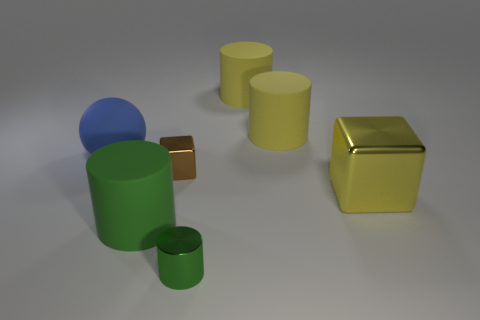The metallic object in front of the large rubber cylinder that is in front of the big metallic thing is what color? The metallic object you're referring to, positioned in front of the large rubber cylinder and itself in front of a sizeable metal structure, is green. 